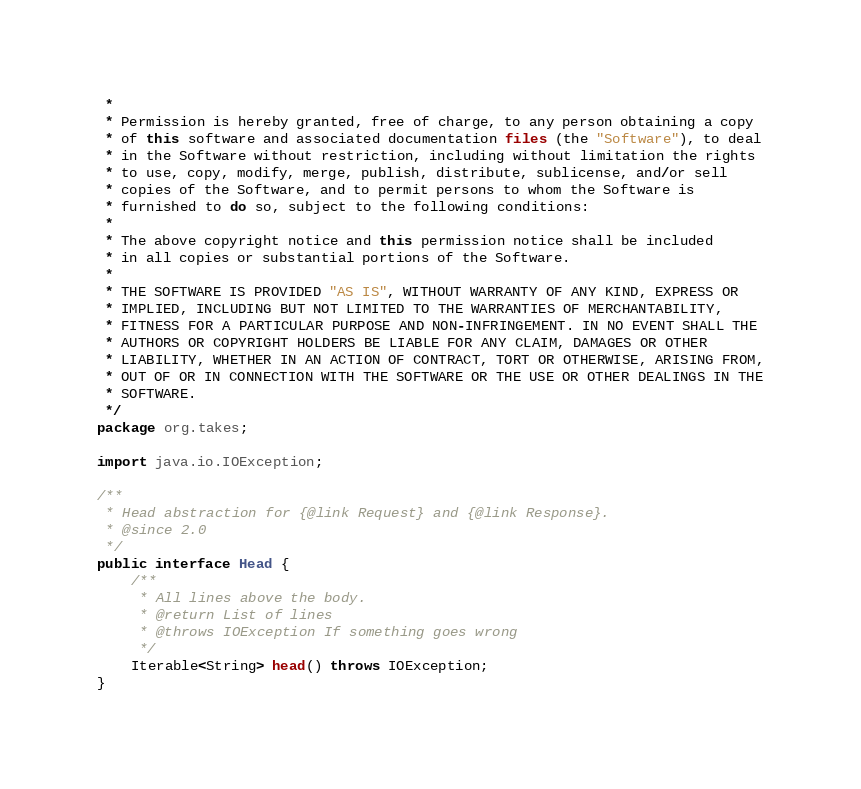Convert code to text. <code><loc_0><loc_0><loc_500><loc_500><_Java_> *
 * Permission is hereby granted, free of charge, to any person obtaining a copy
 * of this software and associated documentation files (the "Software"), to deal
 * in the Software without restriction, including without limitation the rights
 * to use, copy, modify, merge, publish, distribute, sublicense, and/or sell
 * copies of the Software, and to permit persons to whom the Software is
 * furnished to do so, subject to the following conditions:
 *
 * The above copyright notice and this permission notice shall be included
 * in all copies or substantial portions of the Software.
 *
 * THE SOFTWARE IS PROVIDED "AS IS", WITHOUT WARRANTY OF ANY KIND, EXPRESS OR
 * IMPLIED, INCLUDING BUT NOT LIMITED TO THE WARRANTIES OF MERCHANTABILITY,
 * FITNESS FOR A PARTICULAR PURPOSE AND NON-INFRINGEMENT. IN NO EVENT SHALL THE
 * AUTHORS OR COPYRIGHT HOLDERS BE LIABLE FOR ANY CLAIM, DAMAGES OR OTHER
 * LIABILITY, WHETHER IN AN ACTION OF CONTRACT, TORT OR OTHERWISE, ARISING FROM,
 * OUT OF OR IN CONNECTION WITH THE SOFTWARE OR THE USE OR OTHER DEALINGS IN THE
 * SOFTWARE.
 */
package org.takes;

import java.io.IOException;

/**
 * Head abstraction for {@link Request} and {@link Response}.
 * @since 2.0
 */
public interface Head {
    /**
     * All lines above the body.
     * @return List of lines
     * @throws IOException If something goes wrong
     */
    Iterable<String> head() throws IOException;
}
</code> 